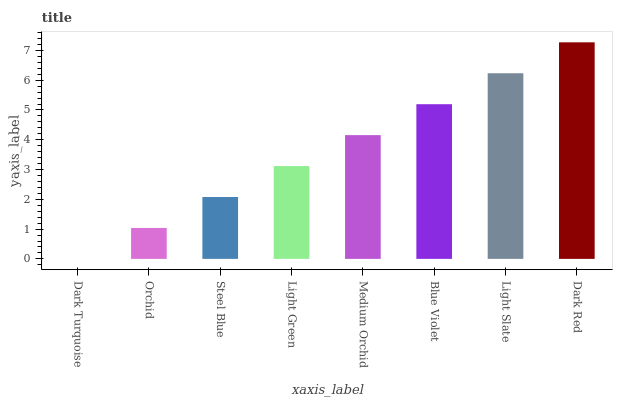Is Dark Turquoise the minimum?
Answer yes or no. Yes. Is Dark Red the maximum?
Answer yes or no. Yes. Is Orchid the minimum?
Answer yes or no. No. Is Orchid the maximum?
Answer yes or no. No. Is Orchid greater than Dark Turquoise?
Answer yes or no. Yes. Is Dark Turquoise less than Orchid?
Answer yes or no. Yes. Is Dark Turquoise greater than Orchid?
Answer yes or no. No. Is Orchid less than Dark Turquoise?
Answer yes or no. No. Is Medium Orchid the high median?
Answer yes or no. Yes. Is Light Green the low median?
Answer yes or no. Yes. Is Light Green the high median?
Answer yes or no. No. Is Dark Turquoise the low median?
Answer yes or no. No. 